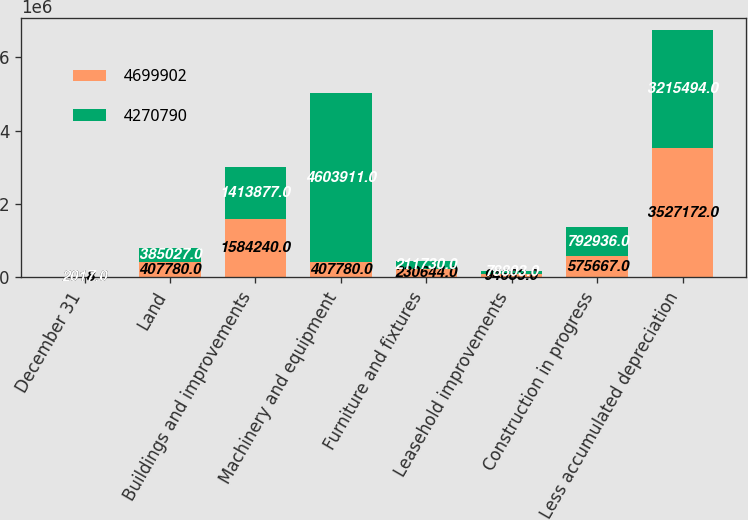Convert chart. <chart><loc_0><loc_0><loc_500><loc_500><stacked_bar_chart><ecel><fcel>December 31<fcel>Land<fcel>Buildings and improvements<fcel>Machinery and equipment<fcel>Furniture and fixtures<fcel>Leasehold improvements<fcel>Construction in progress<fcel>Less accumulated depreciation<nl><fcel>4.6999e+06<fcel>2018<fcel>407780<fcel>1.58424e+06<fcel>407780<fcel>230644<fcel>94683<fcel>575667<fcel>3.52717e+06<nl><fcel>4.27079e+06<fcel>2017<fcel>385027<fcel>1.41388e+06<fcel>4.60391e+06<fcel>211730<fcel>78803<fcel>792936<fcel>3.21549e+06<nl></chart> 